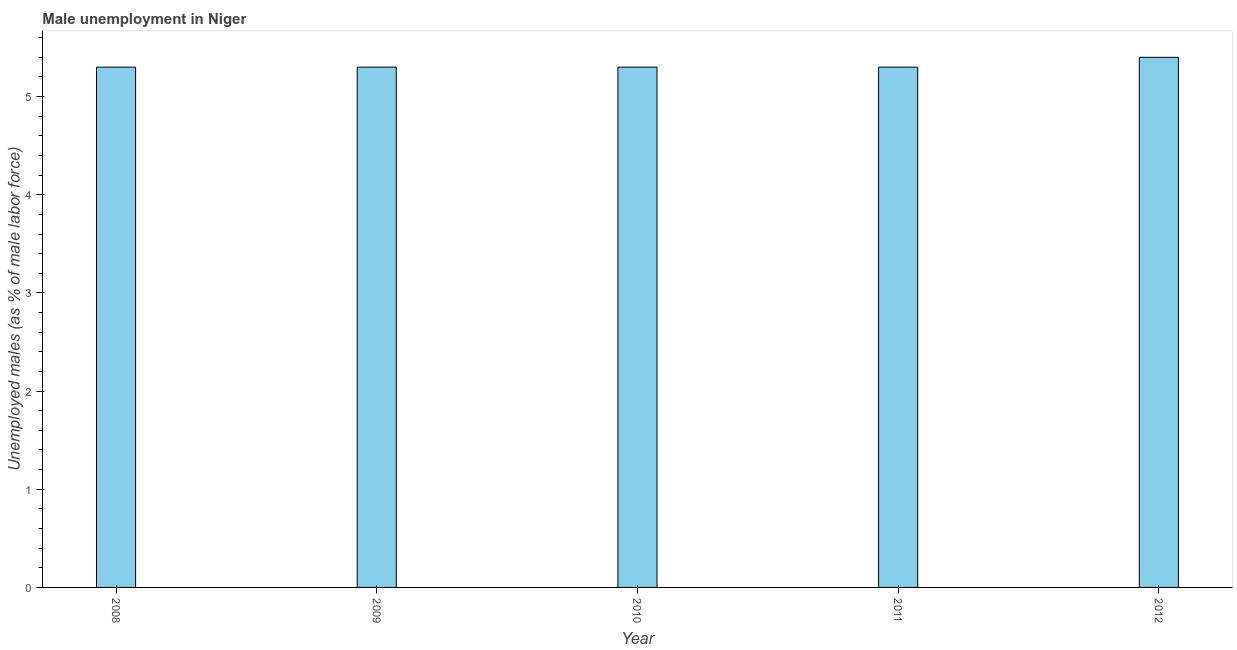Does the graph contain any zero values?
Provide a short and direct response. No. What is the title of the graph?
Provide a short and direct response. Male unemployment in Niger. What is the label or title of the X-axis?
Ensure brevity in your answer.  Year. What is the label or title of the Y-axis?
Offer a very short reply. Unemployed males (as % of male labor force). What is the unemployed males population in 2008?
Offer a terse response. 5.3. Across all years, what is the maximum unemployed males population?
Ensure brevity in your answer.  5.4. Across all years, what is the minimum unemployed males population?
Your answer should be very brief. 5.3. In which year was the unemployed males population maximum?
Keep it short and to the point. 2012. In which year was the unemployed males population minimum?
Your answer should be compact. 2008. What is the sum of the unemployed males population?
Keep it short and to the point. 26.6. What is the average unemployed males population per year?
Offer a terse response. 5.32. What is the median unemployed males population?
Offer a very short reply. 5.3. In how many years, is the unemployed males population greater than 5.4 %?
Your answer should be very brief. 1. What is the ratio of the unemployed males population in 2010 to that in 2011?
Keep it short and to the point. 1. Is the unemployed males population in 2008 less than that in 2012?
Keep it short and to the point. Yes. What is the difference between the highest and the lowest unemployed males population?
Make the answer very short. 0.1. In how many years, is the unemployed males population greater than the average unemployed males population taken over all years?
Make the answer very short. 1. Are all the bars in the graph horizontal?
Give a very brief answer. No. What is the Unemployed males (as % of male labor force) in 2008?
Your answer should be compact. 5.3. What is the Unemployed males (as % of male labor force) in 2009?
Offer a terse response. 5.3. What is the Unemployed males (as % of male labor force) of 2010?
Ensure brevity in your answer.  5.3. What is the Unemployed males (as % of male labor force) of 2011?
Your answer should be compact. 5.3. What is the Unemployed males (as % of male labor force) in 2012?
Offer a terse response. 5.4. What is the difference between the Unemployed males (as % of male labor force) in 2008 and 2009?
Give a very brief answer. 0. What is the difference between the Unemployed males (as % of male labor force) in 2009 and 2012?
Provide a succinct answer. -0.1. What is the difference between the Unemployed males (as % of male labor force) in 2010 and 2012?
Your response must be concise. -0.1. What is the difference between the Unemployed males (as % of male labor force) in 2011 and 2012?
Provide a short and direct response. -0.1. What is the ratio of the Unemployed males (as % of male labor force) in 2008 to that in 2009?
Provide a short and direct response. 1. What is the ratio of the Unemployed males (as % of male labor force) in 2008 to that in 2010?
Offer a very short reply. 1. What is the ratio of the Unemployed males (as % of male labor force) in 2008 to that in 2011?
Your answer should be compact. 1. What is the ratio of the Unemployed males (as % of male labor force) in 2008 to that in 2012?
Keep it short and to the point. 0.98. What is the ratio of the Unemployed males (as % of male labor force) in 2009 to that in 2012?
Provide a succinct answer. 0.98. 